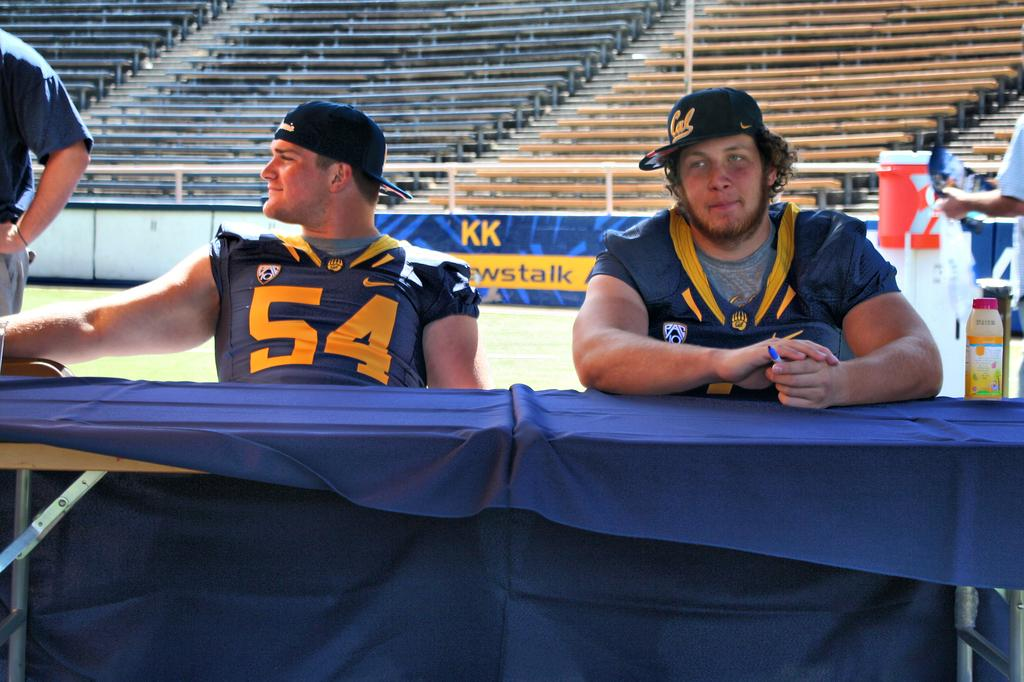Provide a one-sentence caption for the provided image. Two sport players are sitting at a table and one of the jerseys reads "54". 